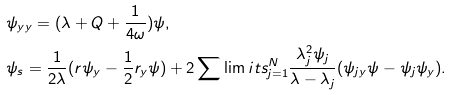Convert formula to latex. <formula><loc_0><loc_0><loc_500><loc_500>& \psi _ { y y } = ( \lambda + Q + \frac { 1 } { 4 \omega } ) \psi , \\ & \psi _ { s } = \frac { 1 } { 2 \lambda } ( r \psi _ { y } - \frac { 1 } { 2 } r _ { y } \psi ) + 2 \sum \lim i t s _ { j = 1 } ^ { N } \frac { \lambda _ { j } ^ { 2 } \psi _ { j } } { \lambda - \lambda _ { j } } ( \psi _ { j y } \psi - \psi _ { j } \psi _ { y } ) .</formula> 